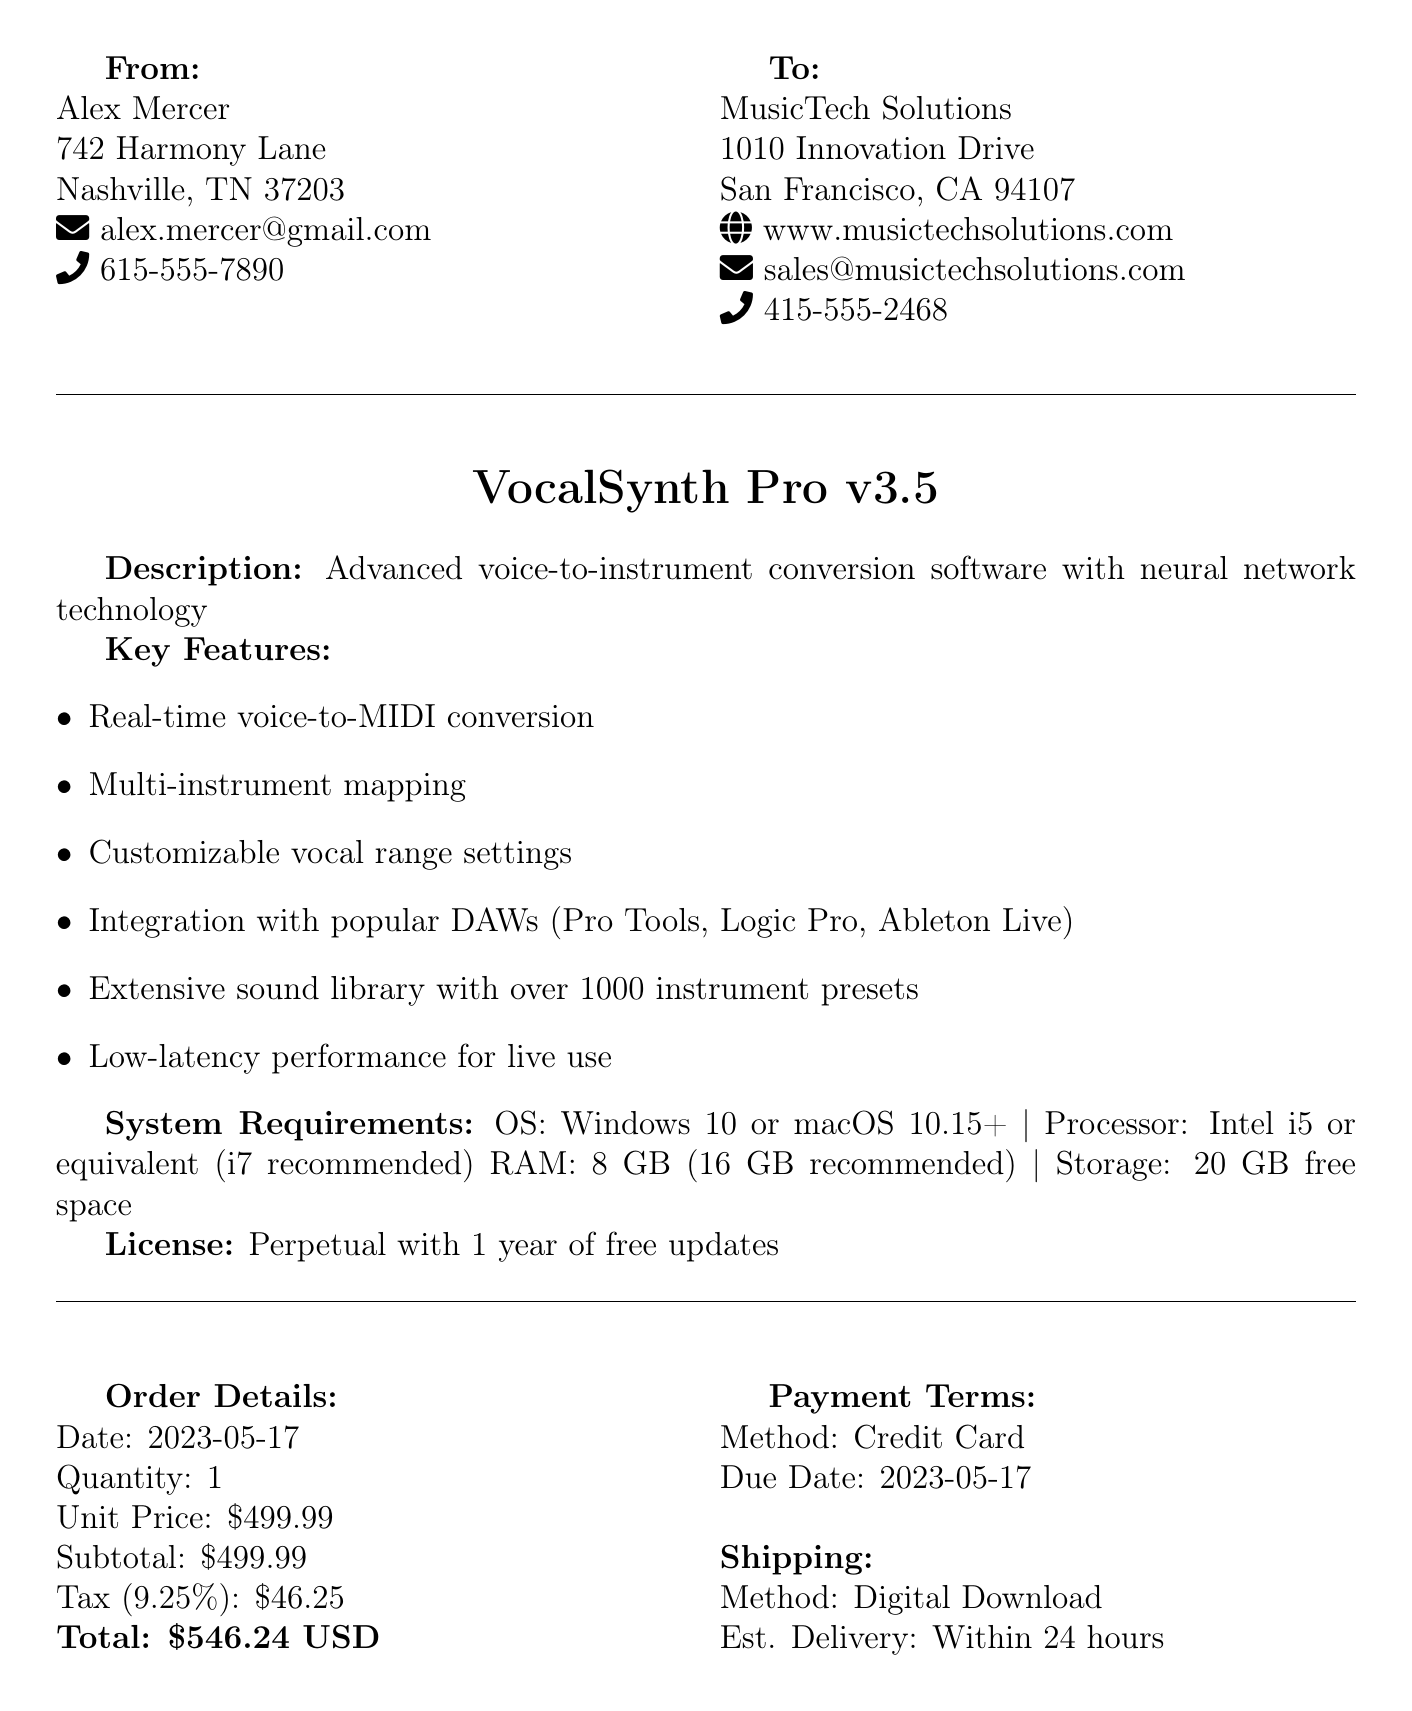what is the name of the software? The name of the software is mentioned in the document as VocalSynth Pro.
Answer: VocalSynth Pro who is the purchaser? The purchaser's name is given in the document as Alex Mercer.
Answer: Alex Mercer what is the total amount due? The total amount due is clearly listed in the order details as $546.24.
Answer: $546.24 what payment method is used? The payment method is specified in the document as Credit Card.
Answer: Credit Card what is the estimated delivery method? The document states that the estimated delivery method for the software is Digital Download.
Answer: Digital Download how many instrument presets does the software have? The number of instrument presets available in the software is mentioned as over 1000.
Answer: over 1000 what is the tax rate applied? The tax rate for the order is noted in the document as 9.25 percent.
Answer: 9.25 percent who is the support contact person? The document specifies that the support contact person is Emma Thompson.
Answer: Emma Thompson what additional service is included for free? The document indicates that a complimentary 2-hour online training session is included.
Answer: 2-hour online training session 